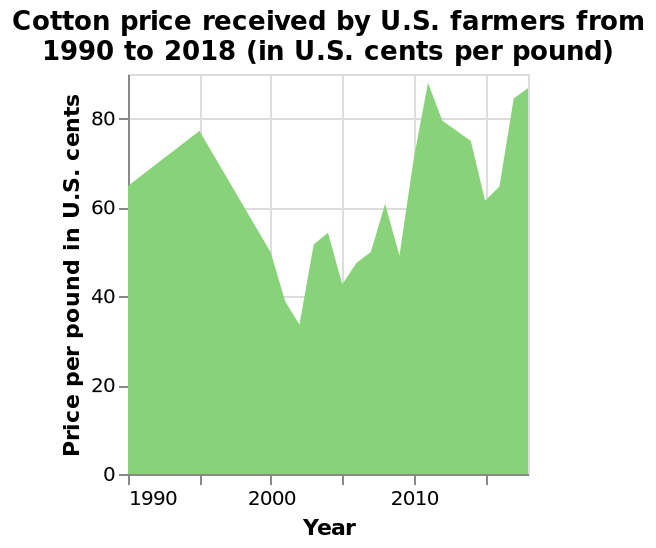<image>
Was there any fluctuation in the price of cotton over time? Yes, there were some fluctuations in the price of cotton. When did cotton costs reach their lowest level in 2000?  Cotton costs reached their lowest level in 2000. please enumerates aspects of the construction of the chart Here a area diagram is called Cotton price received by U.S. farmers from 1990 to 2018 (in U.S. cents per pound). Year is measured as a linear scale with a minimum of 1990 and a maximum of 2015 on the x-axis. A linear scale from 0 to 80 can be found along the y-axis, marked Price per pound in U.S. cents. 